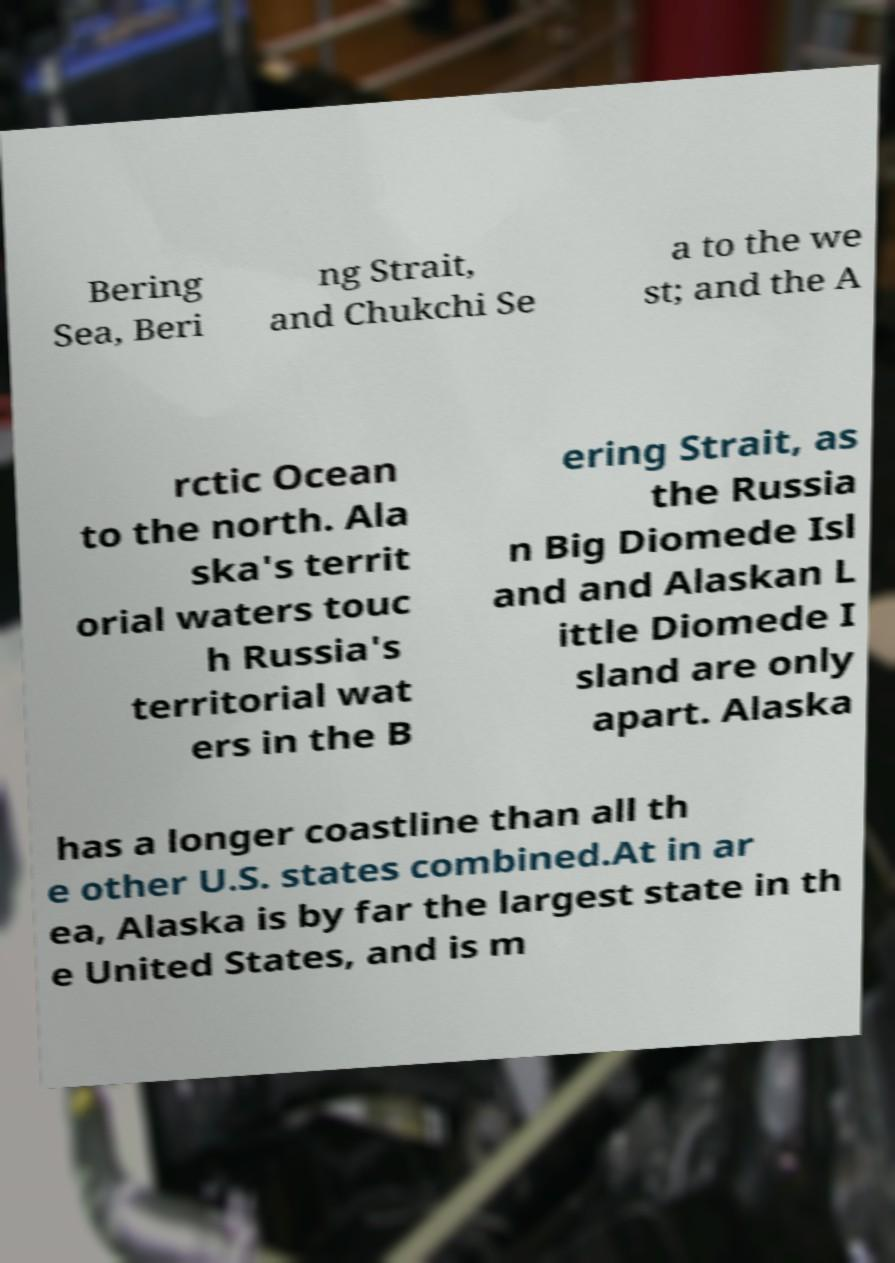Can you accurately transcribe the text from the provided image for me? Bering Sea, Beri ng Strait, and Chukchi Se a to the we st; and the A rctic Ocean to the north. Ala ska's territ orial waters touc h Russia's territorial wat ers in the B ering Strait, as the Russia n Big Diomede Isl and and Alaskan L ittle Diomede I sland are only apart. Alaska has a longer coastline than all th e other U.S. states combined.At in ar ea, Alaska is by far the largest state in th e United States, and is m 